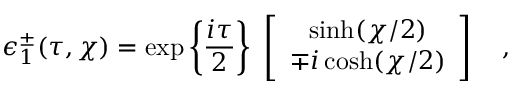Convert formula to latex. <formula><loc_0><loc_0><loc_500><loc_500>\epsilon _ { 1 } ^ { \pm } ( \tau , \chi ) = \exp \left \{ { \frac { i \tau } { 2 } } \right \} \left [ \begin{array} { c } { \sinh ( \chi / 2 ) } \\ { \mp i \cosh ( \chi / 2 ) } \end{array} \right ] ,</formula> 